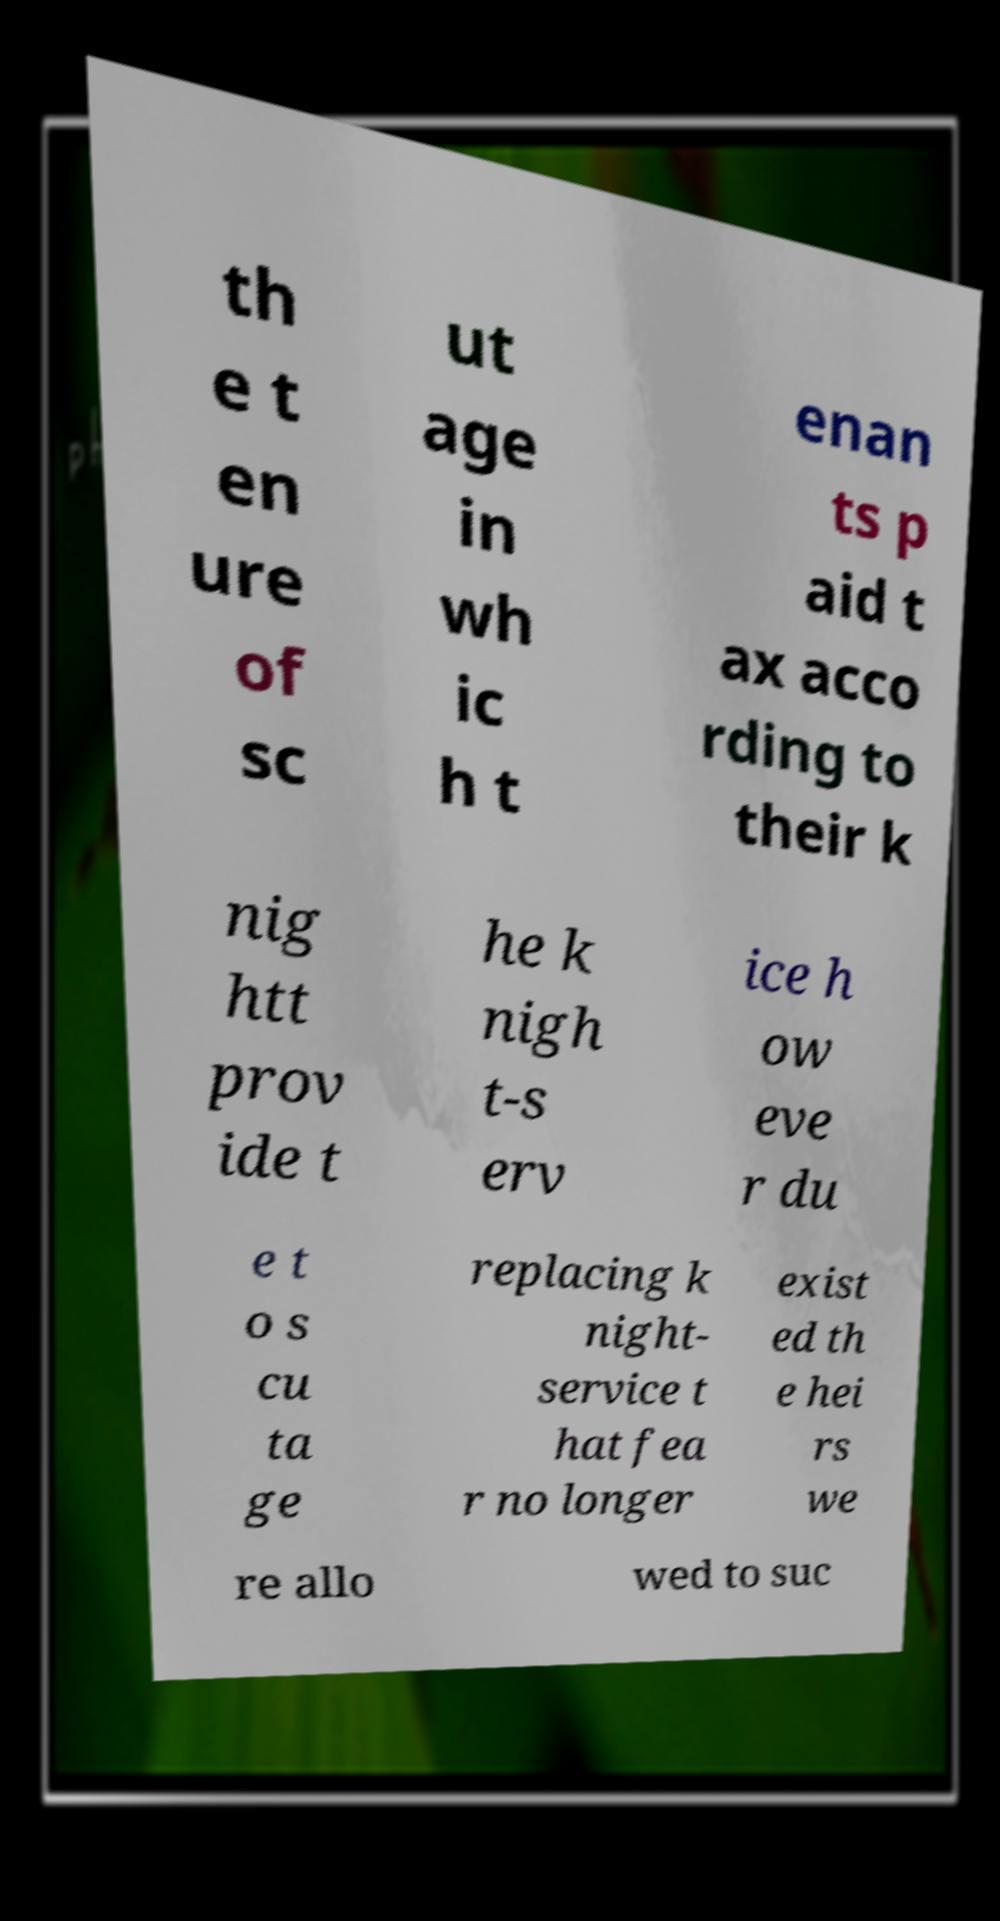Can you accurately transcribe the text from the provided image for me? th e t en ure of sc ut age in wh ic h t enan ts p aid t ax acco rding to their k nig htt prov ide t he k nigh t-s erv ice h ow eve r du e t o s cu ta ge replacing k night- service t hat fea r no longer exist ed th e hei rs we re allo wed to suc 